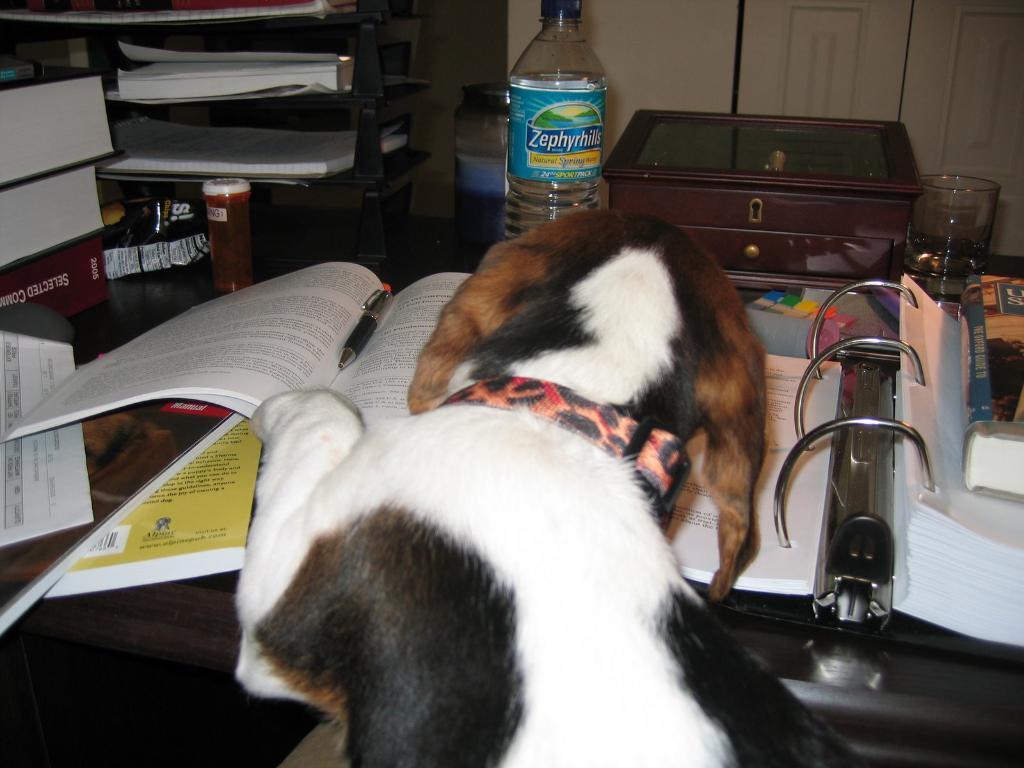Please provide a concise description of this image. In the picture I can see a dog and there is a table in front of it which has few books,water bottle,box,glass and some other objects on it 